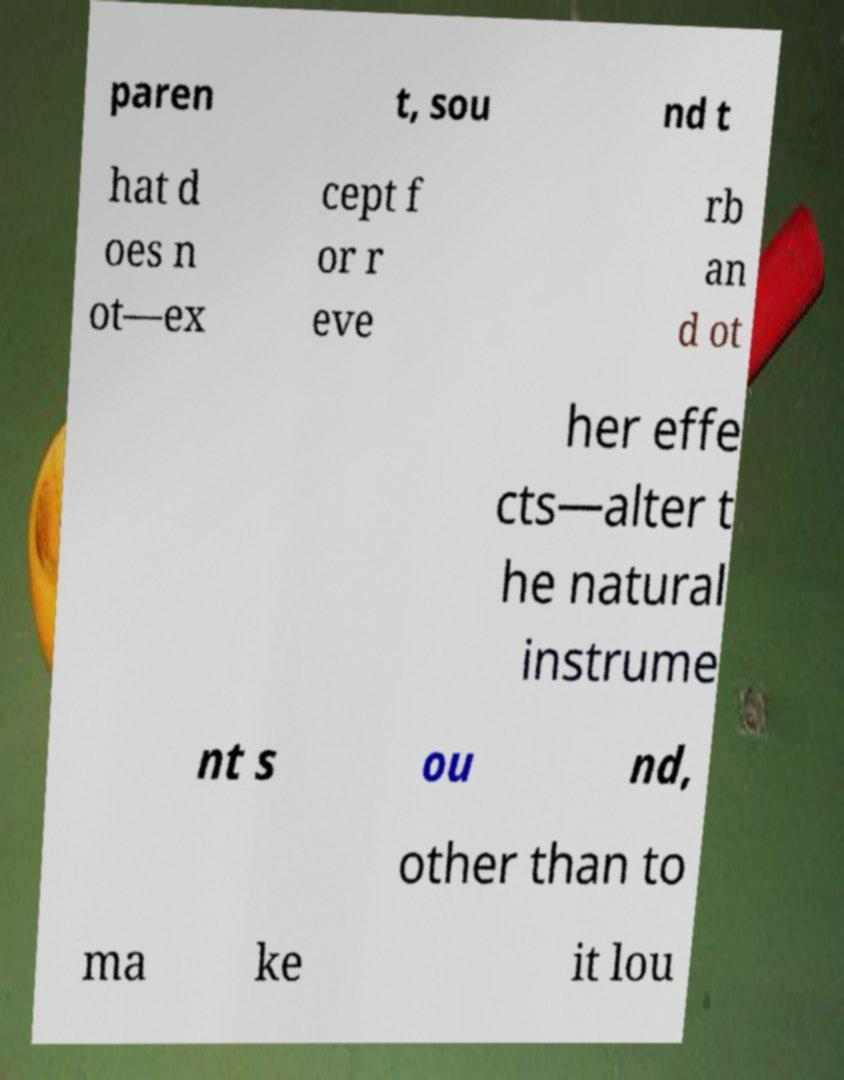What messages or text are displayed in this image? I need them in a readable, typed format. paren t, sou nd t hat d oes n ot—ex cept f or r eve rb an d ot her effe cts—alter t he natural instrume nt s ou nd, other than to ma ke it lou 